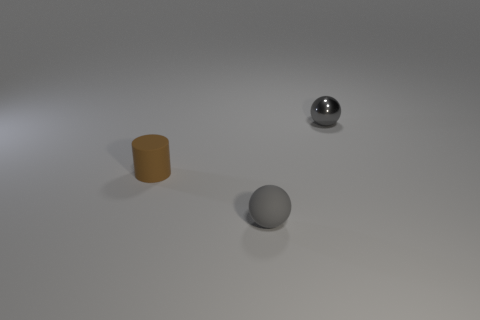Add 1 tiny rubber objects. How many objects exist? 4 Subtract all spheres. How many objects are left? 1 Add 1 big gray metal cylinders. How many big gray metal cylinders exist? 1 Subtract 0 yellow cylinders. How many objects are left? 3 Subtract all small green shiny cubes. Subtract all tiny gray balls. How many objects are left? 1 Add 1 metal balls. How many metal balls are left? 2 